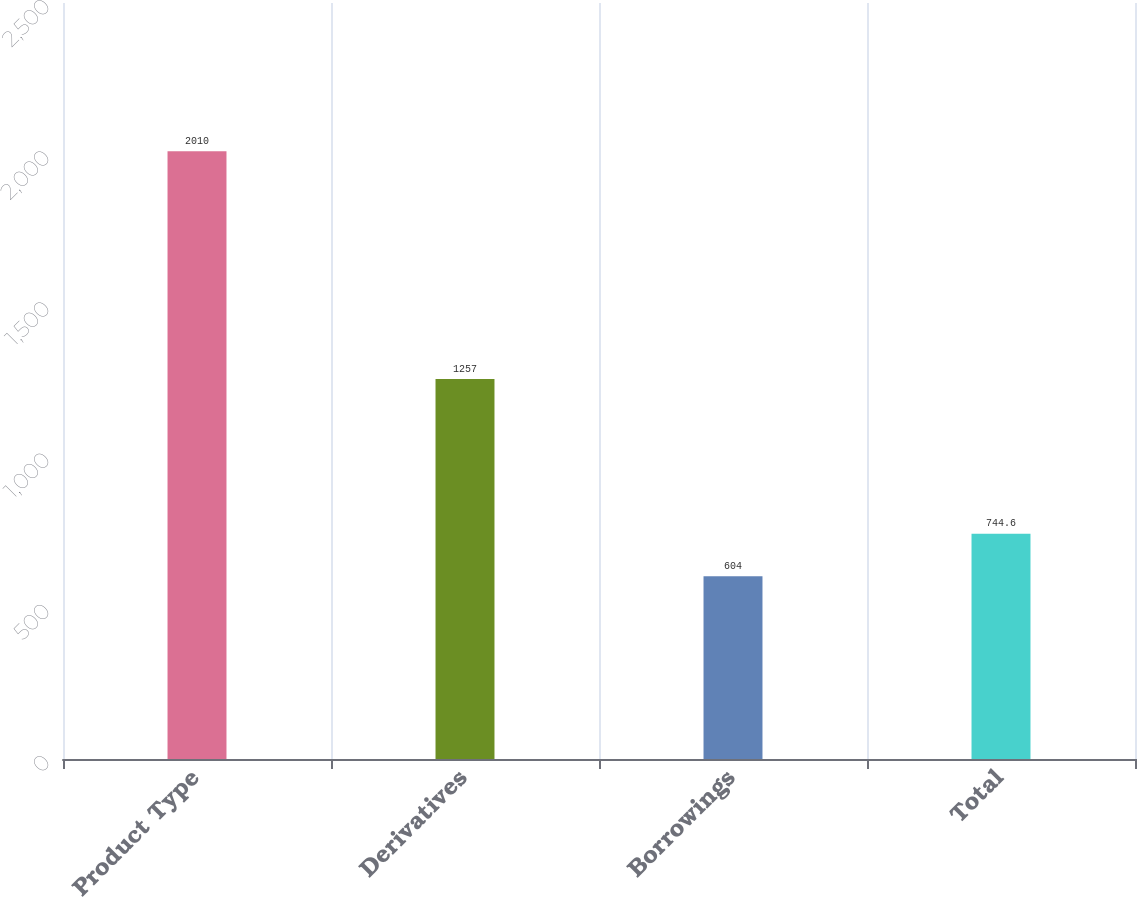Convert chart. <chart><loc_0><loc_0><loc_500><loc_500><bar_chart><fcel>Product Type<fcel>Derivatives<fcel>Borrowings<fcel>Total<nl><fcel>2010<fcel>1257<fcel>604<fcel>744.6<nl></chart> 